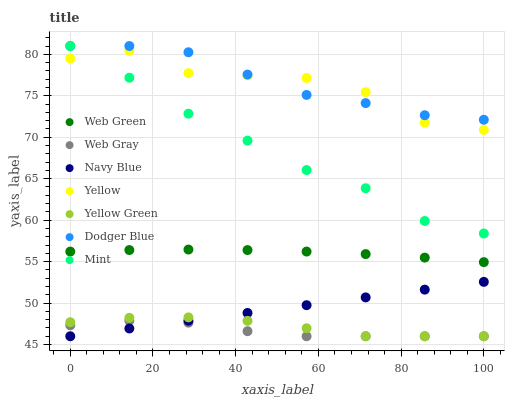Does Web Gray have the minimum area under the curve?
Answer yes or no. Yes. Does Dodger Blue have the maximum area under the curve?
Answer yes or no. Yes. Does Yellow Green have the minimum area under the curve?
Answer yes or no. No. Does Yellow Green have the maximum area under the curve?
Answer yes or no. No. Is Navy Blue the smoothest?
Answer yes or no. Yes. Is Yellow the roughest?
Answer yes or no. Yes. Is Yellow Green the smoothest?
Answer yes or no. No. Is Yellow Green the roughest?
Answer yes or no. No. Does Web Gray have the lowest value?
Answer yes or no. Yes. Does Yellow have the lowest value?
Answer yes or no. No. Does Mint have the highest value?
Answer yes or no. Yes. Does Yellow Green have the highest value?
Answer yes or no. No. Is Web Green less than Yellow?
Answer yes or no. Yes. Is Yellow greater than Web Gray?
Answer yes or no. Yes. Does Yellow intersect Dodger Blue?
Answer yes or no. Yes. Is Yellow less than Dodger Blue?
Answer yes or no. No. Is Yellow greater than Dodger Blue?
Answer yes or no. No. Does Web Green intersect Yellow?
Answer yes or no. No. 